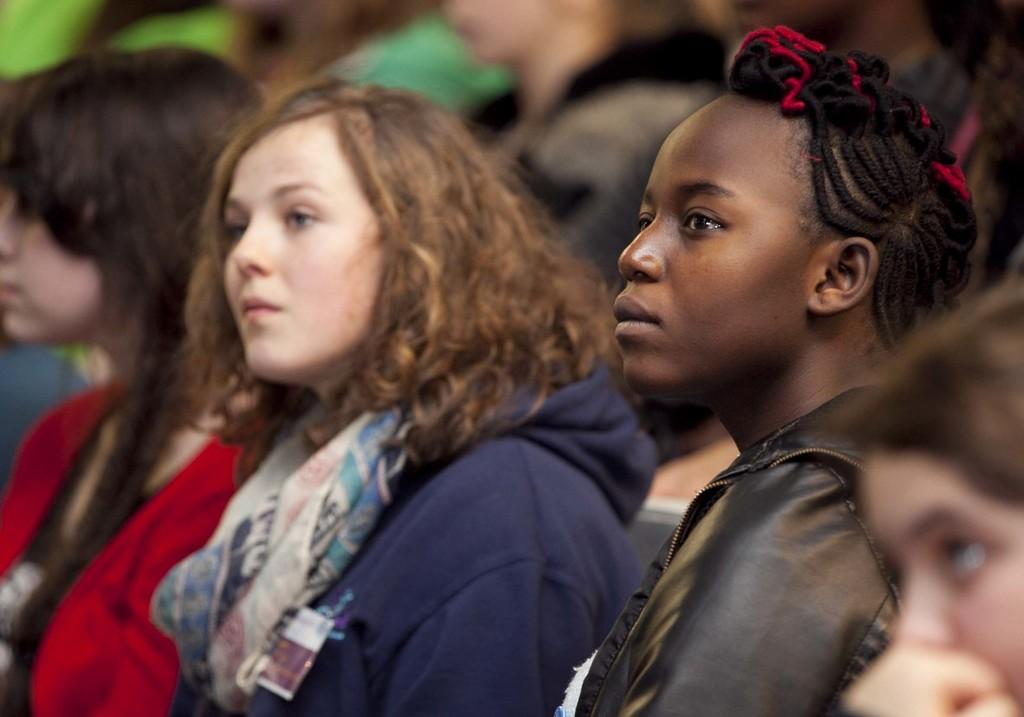How many people are in the image? There are persons in the image. What can be observed about the attire of the persons? The persons are wearing different color dresses. What are the persons doing in the image? The persons are watching something. Can you describe the background of the image? The background of the image is blurred. What type of lace is being distributed to the crowd in the image? There is no crowd or lace present in the image. 